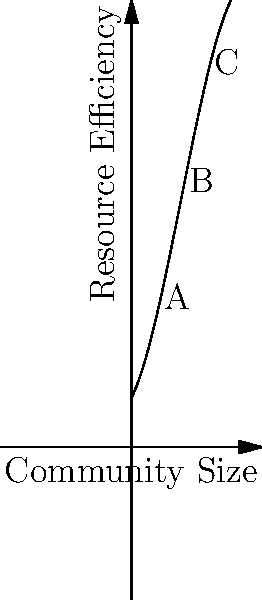The graph represents the relationship between community size and resource efficiency in a communal living setting. The function is given by $f(x) = -0.01x^3 + 0.3x^2 + 2x + 10$, where $x$ is the number of people in the community and $f(x)$ is the resource efficiency index. At which point (A, B, or C) does the community achieve the highest resource efficiency? Explain your reasoning. To determine the point of highest resource efficiency, we need to compare the y-values (resource efficiency index) at points A, B, and C:

1. Point A: $x = 5$
   $f(5) = -0.01(5^3) + 0.3(5^2) + 2(5) + 10 = 22.75$

2. Point B: $x = 10$
   $f(10) = -0.01(10^3) + 0.3(10^2) + 2(10) + 10 = 40$

3. Point C: $x = 15$
   $f(15) = -0.01(15^3) + 0.3(15^2) + 2(15) + 10 = 47.75$

Comparing these values, we can see that:
$f(15) > f(10) > f(5)$

Therefore, point C (at $x = 15$) has the highest resource efficiency index.

This result suggests that in this model, as the community size increases up to 15 people, the resource efficiency continues to improve. This could be due to factors such as economies of scale, diverse skill sets, and shared resources in larger communities.
Answer: Point C 